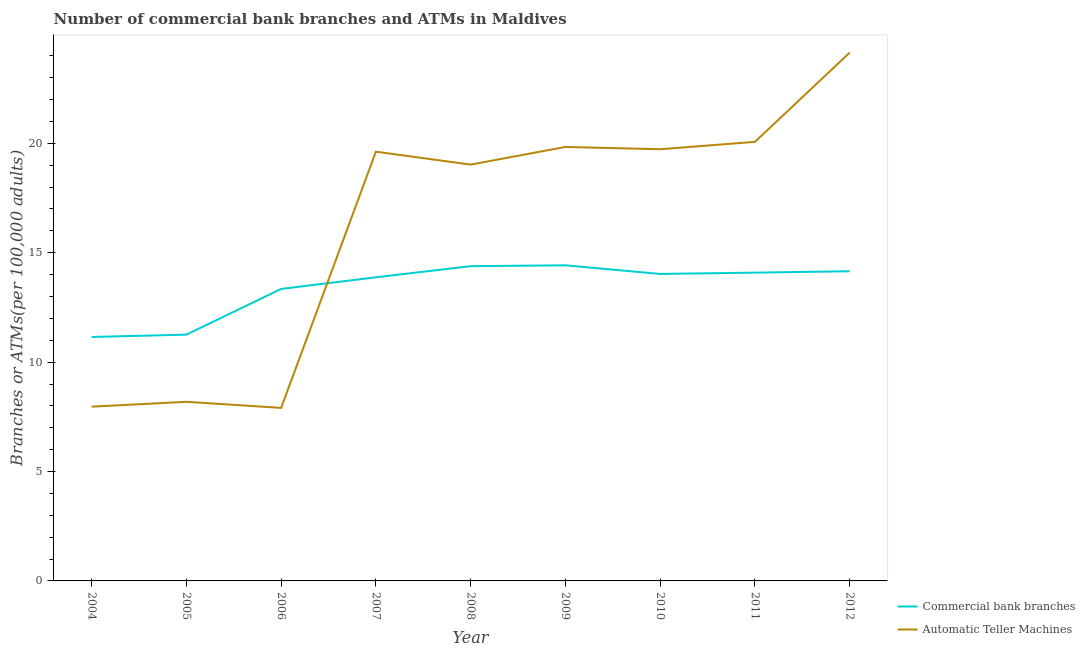What is the number of commercal bank branches in 2010?
Provide a succinct answer. 14.03. Across all years, what is the maximum number of atms?
Offer a terse response. 24.15. Across all years, what is the minimum number of atms?
Ensure brevity in your answer.  7.91. In which year was the number of commercal bank branches minimum?
Make the answer very short. 2004. What is the total number of atms in the graph?
Keep it short and to the point. 146.49. What is the difference between the number of atms in 2007 and that in 2010?
Your response must be concise. -0.11. What is the difference between the number of commercal bank branches in 2004 and the number of atms in 2008?
Ensure brevity in your answer.  -7.88. What is the average number of commercal bank branches per year?
Your answer should be compact. 13.41. In the year 2010, what is the difference between the number of commercal bank branches and number of atms?
Offer a terse response. -5.7. What is the ratio of the number of atms in 2007 to that in 2008?
Ensure brevity in your answer.  1.03. What is the difference between the highest and the second highest number of commercal bank branches?
Keep it short and to the point. 0.04. What is the difference between the highest and the lowest number of commercal bank branches?
Make the answer very short. 3.28. In how many years, is the number of atms greater than the average number of atms taken over all years?
Keep it short and to the point. 6. Does the number of commercal bank branches monotonically increase over the years?
Provide a succinct answer. No. Is the number of commercal bank branches strictly less than the number of atms over the years?
Offer a terse response. No. How many years are there in the graph?
Provide a succinct answer. 9. What is the difference between two consecutive major ticks on the Y-axis?
Provide a succinct answer. 5. Are the values on the major ticks of Y-axis written in scientific E-notation?
Provide a succinct answer. No. Does the graph contain any zero values?
Make the answer very short. No. Does the graph contain grids?
Offer a terse response. No. Where does the legend appear in the graph?
Offer a terse response. Bottom right. What is the title of the graph?
Provide a succinct answer. Number of commercial bank branches and ATMs in Maldives. What is the label or title of the Y-axis?
Your response must be concise. Branches or ATMs(per 100,0 adults). What is the Branches or ATMs(per 100,000 adults) of Commercial bank branches in 2004?
Ensure brevity in your answer.  11.15. What is the Branches or ATMs(per 100,000 adults) of Automatic Teller Machines in 2004?
Your response must be concise. 7.96. What is the Branches or ATMs(per 100,000 adults) of Commercial bank branches in 2005?
Offer a very short reply. 11.26. What is the Branches or ATMs(per 100,000 adults) of Automatic Teller Machines in 2005?
Offer a very short reply. 8.19. What is the Branches or ATMs(per 100,000 adults) in Commercial bank branches in 2006?
Offer a terse response. 13.35. What is the Branches or ATMs(per 100,000 adults) in Automatic Teller Machines in 2006?
Ensure brevity in your answer.  7.91. What is the Branches or ATMs(per 100,000 adults) in Commercial bank branches in 2007?
Ensure brevity in your answer.  13.88. What is the Branches or ATMs(per 100,000 adults) in Automatic Teller Machines in 2007?
Give a very brief answer. 19.62. What is the Branches or ATMs(per 100,000 adults) of Commercial bank branches in 2008?
Your answer should be very brief. 14.39. What is the Branches or ATMs(per 100,000 adults) of Automatic Teller Machines in 2008?
Your answer should be compact. 19.03. What is the Branches or ATMs(per 100,000 adults) of Commercial bank branches in 2009?
Your response must be concise. 14.43. What is the Branches or ATMs(per 100,000 adults) in Automatic Teller Machines in 2009?
Your answer should be very brief. 19.83. What is the Branches or ATMs(per 100,000 adults) of Commercial bank branches in 2010?
Give a very brief answer. 14.03. What is the Branches or ATMs(per 100,000 adults) of Automatic Teller Machines in 2010?
Your answer should be compact. 19.73. What is the Branches or ATMs(per 100,000 adults) of Commercial bank branches in 2011?
Ensure brevity in your answer.  14.09. What is the Branches or ATMs(per 100,000 adults) of Automatic Teller Machines in 2011?
Your answer should be very brief. 20.07. What is the Branches or ATMs(per 100,000 adults) of Commercial bank branches in 2012?
Your answer should be very brief. 14.15. What is the Branches or ATMs(per 100,000 adults) in Automatic Teller Machines in 2012?
Keep it short and to the point. 24.15. Across all years, what is the maximum Branches or ATMs(per 100,000 adults) in Commercial bank branches?
Keep it short and to the point. 14.43. Across all years, what is the maximum Branches or ATMs(per 100,000 adults) in Automatic Teller Machines?
Your answer should be very brief. 24.15. Across all years, what is the minimum Branches or ATMs(per 100,000 adults) in Commercial bank branches?
Give a very brief answer. 11.15. Across all years, what is the minimum Branches or ATMs(per 100,000 adults) in Automatic Teller Machines?
Offer a very short reply. 7.91. What is the total Branches or ATMs(per 100,000 adults) in Commercial bank branches in the graph?
Your answer should be very brief. 120.72. What is the total Branches or ATMs(per 100,000 adults) in Automatic Teller Machines in the graph?
Offer a very short reply. 146.49. What is the difference between the Branches or ATMs(per 100,000 adults) of Commercial bank branches in 2004 and that in 2005?
Provide a succinct answer. -0.11. What is the difference between the Branches or ATMs(per 100,000 adults) in Automatic Teller Machines in 2004 and that in 2005?
Your response must be concise. -0.22. What is the difference between the Branches or ATMs(per 100,000 adults) of Commercial bank branches in 2004 and that in 2006?
Offer a very short reply. -2.2. What is the difference between the Branches or ATMs(per 100,000 adults) in Automatic Teller Machines in 2004 and that in 2006?
Offer a very short reply. 0.05. What is the difference between the Branches or ATMs(per 100,000 adults) in Commercial bank branches in 2004 and that in 2007?
Your response must be concise. -2.73. What is the difference between the Branches or ATMs(per 100,000 adults) in Automatic Teller Machines in 2004 and that in 2007?
Keep it short and to the point. -11.66. What is the difference between the Branches or ATMs(per 100,000 adults) of Commercial bank branches in 2004 and that in 2008?
Provide a short and direct response. -3.24. What is the difference between the Branches or ATMs(per 100,000 adults) in Automatic Teller Machines in 2004 and that in 2008?
Provide a succinct answer. -11.06. What is the difference between the Branches or ATMs(per 100,000 adults) of Commercial bank branches in 2004 and that in 2009?
Your response must be concise. -3.28. What is the difference between the Branches or ATMs(per 100,000 adults) of Automatic Teller Machines in 2004 and that in 2009?
Ensure brevity in your answer.  -11.87. What is the difference between the Branches or ATMs(per 100,000 adults) of Commercial bank branches in 2004 and that in 2010?
Your answer should be compact. -2.88. What is the difference between the Branches or ATMs(per 100,000 adults) in Automatic Teller Machines in 2004 and that in 2010?
Make the answer very short. -11.77. What is the difference between the Branches or ATMs(per 100,000 adults) in Commercial bank branches in 2004 and that in 2011?
Provide a succinct answer. -2.94. What is the difference between the Branches or ATMs(per 100,000 adults) of Automatic Teller Machines in 2004 and that in 2011?
Your response must be concise. -12.1. What is the difference between the Branches or ATMs(per 100,000 adults) in Commercial bank branches in 2004 and that in 2012?
Provide a short and direct response. -3. What is the difference between the Branches or ATMs(per 100,000 adults) of Automatic Teller Machines in 2004 and that in 2012?
Give a very brief answer. -16.18. What is the difference between the Branches or ATMs(per 100,000 adults) in Commercial bank branches in 2005 and that in 2006?
Provide a short and direct response. -2.09. What is the difference between the Branches or ATMs(per 100,000 adults) in Automatic Teller Machines in 2005 and that in 2006?
Provide a succinct answer. 0.28. What is the difference between the Branches or ATMs(per 100,000 adults) of Commercial bank branches in 2005 and that in 2007?
Give a very brief answer. -2.62. What is the difference between the Branches or ATMs(per 100,000 adults) in Automatic Teller Machines in 2005 and that in 2007?
Your answer should be very brief. -11.43. What is the difference between the Branches or ATMs(per 100,000 adults) in Commercial bank branches in 2005 and that in 2008?
Provide a short and direct response. -3.13. What is the difference between the Branches or ATMs(per 100,000 adults) in Automatic Teller Machines in 2005 and that in 2008?
Keep it short and to the point. -10.84. What is the difference between the Branches or ATMs(per 100,000 adults) in Commercial bank branches in 2005 and that in 2009?
Your response must be concise. -3.17. What is the difference between the Branches or ATMs(per 100,000 adults) of Automatic Teller Machines in 2005 and that in 2009?
Keep it short and to the point. -11.65. What is the difference between the Branches or ATMs(per 100,000 adults) in Commercial bank branches in 2005 and that in 2010?
Your response must be concise. -2.77. What is the difference between the Branches or ATMs(per 100,000 adults) in Automatic Teller Machines in 2005 and that in 2010?
Keep it short and to the point. -11.54. What is the difference between the Branches or ATMs(per 100,000 adults) in Commercial bank branches in 2005 and that in 2011?
Offer a very short reply. -2.83. What is the difference between the Branches or ATMs(per 100,000 adults) in Automatic Teller Machines in 2005 and that in 2011?
Your answer should be very brief. -11.88. What is the difference between the Branches or ATMs(per 100,000 adults) of Commercial bank branches in 2005 and that in 2012?
Keep it short and to the point. -2.9. What is the difference between the Branches or ATMs(per 100,000 adults) in Automatic Teller Machines in 2005 and that in 2012?
Provide a short and direct response. -15.96. What is the difference between the Branches or ATMs(per 100,000 adults) in Commercial bank branches in 2006 and that in 2007?
Give a very brief answer. -0.53. What is the difference between the Branches or ATMs(per 100,000 adults) of Automatic Teller Machines in 2006 and that in 2007?
Your answer should be compact. -11.71. What is the difference between the Branches or ATMs(per 100,000 adults) in Commercial bank branches in 2006 and that in 2008?
Provide a short and direct response. -1.04. What is the difference between the Branches or ATMs(per 100,000 adults) of Automatic Teller Machines in 2006 and that in 2008?
Make the answer very short. -11.12. What is the difference between the Branches or ATMs(per 100,000 adults) in Commercial bank branches in 2006 and that in 2009?
Provide a succinct answer. -1.08. What is the difference between the Branches or ATMs(per 100,000 adults) in Automatic Teller Machines in 2006 and that in 2009?
Provide a succinct answer. -11.93. What is the difference between the Branches or ATMs(per 100,000 adults) in Commercial bank branches in 2006 and that in 2010?
Ensure brevity in your answer.  -0.68. What is the difference between the Branches or ATMs(per 100,000 adults) in Automatic Teller Machines in 2006 and that in 2010?
Provide a short and direct response. -11.82. What is the difference between the Branches or ATMs(per 100,000 adults) of Commercial bank branches in 2006 and that in 2011?
Ensure brevity in your answer.  -0.74. What is the difference between the Branches or ATMs(per 100,000 adults) of Automatic Teller Machines in 2006 and that in 2011?
Offer a very short reply. -12.16. What is the difference between the Branches or ATMs(per 100,000 adults) of Commercial bank branches in 2006 and that in 2012?
Your answer should be compact. -0.81. What is the difference between the Branches or ATMs(per 100,000 adults) of Automatic Teller Machines in 2006 and that in 2012?
Your response must be concise. -16.24. What is the difference between the Branches or ATMs(per 100,000 adults) in Commercial bank branches in 2007 and that in 2008?
Provide a short and direct response. -0.51. What is the difference between the Branches or ATMs(per 100,000 adults) of Automatic Teller Machines in 2007 and that in 2008?
Your answer should be compact. 0.59. What is the difference between the Branches or ATMs(per 100,000 adults) in Commercial bank branches in 2007 and that in 2009?
Give a very brief answer. -0.55. What is the difference between the Branches or ATMs(per 100,000 adults) of Automatic Teller Machines in 2007 and that in 2009?
Your response must be concise. -0.22. What is the difference between the Branches or ATMs(per 100,000 adults) in Commercial bank branches in 2007 and that in 2010?
Offer a terse response. -0.15. What is the difference between the Branches or ATMs(per 100,000 adults) of Automatic Teller Machines in 2007 and that in 2010?
Your answer should be very brief. -0.11. What is the difference between the Branches or ATMs(per 100,000 adults) of Commercial bank branches in 2007 and that in 2011?
Offer a terse response. -0.21. What is the difference between the Branches or ATMs(per 100,000 adults) in Automatic Teller Machines in 2007 and that in 2011?
Offer a terse response. -0.45. What is the difference between the Branches or ATMs(per 100,000 adults) of Commercial bank branches in 2007 and that in 2012?
Your answer should be very brief. -0.28. What is the difference between the Branches or ATMs(per 100,000 adults) in Automatic Teller Machines in 2007 and that in 2012?
Provide a succinct answer. -4.53. What is the difference between the Branches or ATMs(per 100,000 adults) in Commercial bank branches in 2008 and that in 2009?
Provide a short and direct response. -0.04. What is the difference between the Branches or ATMs(per 100,000 adults) of Automatic Teller Machines in 2008 and that in 2009?
Your answer should be compact. -0.81. What is the difference between the Branches or ATMs(per 100,000 adults) of Commercial bank branches in 2008 and that in 2010?
Ensure brevity in your answer.  0.36. What is the difference between the Branches or ATMs(per 100,000 adults) in Automatic Teller Machines in 2008 and that in 2010?
Make the answer very short. -0.7. What is the difference between the Branches or ATMs(per 100,000 adults) of Commercial bank branches in 2008 and that in 2011?
Give a very brief answer. 0.3. What is the difference between the Branches or ATMs(per 100,000 adults) of Automatic Teller Machines in 2008 and that in 2011?
Your response must be concise. -1.04. What is the difference between the Branches or ATMs(per 100,000 adults) of Commercial bank branches in 2008 and that in 2012?
Your answer should be compact. 0.23. What is the difference between the Branches or ATMs(per 100,000 adults) of Automatic Teller Machines in 2008 and that in 2012?
Your answer should be compact. -5.12. What is the difference between the Branches or ATMs(per 100,000 adults) of Commercial bank branches in 2009 and that in 2010?
Ensure brevity in your answer.  0.39. What is the difference between the Branches or ATMs(per 100,000 adults) of Automatic Teller Machines in 2009 and that in 2010?
Provide a short and direct response. 0.1. What is the difference between the Branches or ATMs(per 100,000 adults) in Commercial bank branches in 2009 and that in 2011?
Your response must be concise. 0.33. What is the difference between the Branches or ATMs(per 100,000 adults) in Automatic Teller Machines in 2009 and that in 2011?
Offer a terse response. -0.23. What is the difference between the Branches or ATMs(per 100,000 adults) of Commercial bank branches in 2009 and that in 2012?
Keep it short and to the point. 0.27. What is the difference between the Branches or ATMs(per 100,000 adults) in Automatic Teller Machines in 2009 and that in 2012?
Make the answer very short. -4.31. What is the difference between the Branches or ATMs(per 100,000 adults) in Commercial bank branches in 2010 and that in 2011?
Your answer should be very brief. -0.06. What is the difference between the Branches or ATMs(per 100,000 adults) of Automatic Teller Machines in 2010 and that in 2011?
Provide a short and direct response. -0.34. What is the difference between the Branches or ATMs(per 100,000 adults) in Commercial bank branches in 2010 and that in 2012?
Keep it short and to the point. -0.12. What is the difference between the Branches or ATMs(per 100,000 adults) in Automatic Teller Machines in 2010 and that in 2012?
Offer a very short reply. -4.42. What is the difference between the Branches or ATMs(per 100,000 adults) in Commercial bank branches in 2011 and that in 2012?
Ensure brevity in your answer.  -0.06. What is the difference between the Branches or ATMs(per 100,000 adults) of Automatic Teller Machines in 2011 and that in 2012?
Ensure brevity in your answer.  -4.08. What is the difference between the Branches or ATMs(per 100,000 adults) of Commercial bank branches in 2004 and the Branches or ATMs(per 100,000 adults) of Automatic Teller Machines in 2005?
Offer a very short reply. 2.96. What is the difference between the Branches or ATMs(per 100,000 adults) in Commercial bank branches in 2004 and the Branches or ATMs(per 100,000 adults) in Automatic Teller Machines in 2006?
Give a very brief answer. 3.24. What is the difference between the Branches or ATMs(per 100,000 adults) of Commercial bank branches in 2004 and the Branches or ATMs(per 100,000 adults) of Automatic Teller Machines in 2007?
Your response must be concise. -8.47. What is the difference between the Branches or ATMs(per 100,000 adults) in Commercial bank branches in 2004 and the Branches or ATMs(per 100,000 adults) in Automatic Teller Machines in 2008?
Provide a succinct answer. -7.88. What is the difference between the Branches or ATMs(per 100,000 adults) in Commercial bank branches in 2004 and the Branches or ATMs(per 100,000 adults) in Automatic Teller Machines in 2009?
Your response must be concise. -8.69. What is the difference between the Branches or ATMs(per 100,000 adults) of Commercial bank branches in 2004 and the Branches or ATMs(per 100,000 adults) of Automatic Teller Machines in 2010?
Your response must be concise. -8.58. What is the difference between the Branches or ATMs(per 100,000 adults) of Commercial bank branches in 2004 and the Branches or ATMs(per 100,000 adults) of Automatic Teller Machines in 2011?
Your response must be concise. -8.92. What is the difference between the Branches or ATMs(per 100,000 adults) in Commercial bank branches in 2004 and the Branches or ATMs(per 100,000 adults) in Automatic Teller Machines in 2012?
Keep it short and to the point. -13. What is the difference between the Branches or ATMs(per 100,000 adults) in Commercial bank branches in 2005 and the Branches or ATMs(per 100,000 adults) in Automatic Teller Machines in 2006?
Provide a short and direct response. 3.35. What is the difference between the Branches or ATMs(per 100,000 adults) of Commercial bank branches in 2005 and the Branches or ATMs(per 100,000 adults) of Automatic Teller Machines in 2007?
Your answer should be very brief. -8.36. What is the difference between the Branches or ATMs(per 100,000 adults) of Commercial bank branches in 2005 and the Branches or ATMs(per 100,000 adults) of Automatic Teller Machines in 2008?
Provide a succinct answer. -7.77. What is the difference between the Branches or ATMs(per 100,000 adults) in Commercial bank branches in 2005 and the Branches or ATMs(per 100,000 adults) in Automatic Teller Machines in 2009?
Make the answer very short. -8.58. What is the difference between the Branches or ATMs(per 100,000 adults) of Commercial bank branches in 2005 and the Branches or ATMs(per 100,000 adults) of Automatic Teller Machines in 2010?
Your response must be concise. -8.47. What is the difference between the Branches or ATMs(per 100,000 adults) in Commercial bank branches in 2005 and the Branches or ATMs(per 100,000 adults) in Automatic Teller Machines in 2011?
Offer a very short reply. -8.81. What is the difference between the Branches or ATMs(per 100,000 adults) of Commercial bank branches in 2005 and the Branches or ATMs(per 100,000 adults) of Automatic Teller Machines in 2012?
Provide a short and direct response. -12.89. What is the difference between the Branches or ATMs(per 100,000 adults) in Commercial bank branches in 2006 and the Branches or ATMs(per 100,000 adults) in Automatic Teller Machines in 2007?
Make the answer very short. -6.27. What is the difference between the Branches or ATMs(per 100,000 adults) in Commercial bank branches in 2006 and the Branches or ATMs(per 100,000 adults) in Automatic Teller Machines in 2008?
Your answer should be compact. -5.68. What is the difference between the Branches or ATMs(per 100,000 adults) of Commercial bank branches in 2006 and the Branches or ATMs(per 100,000 adults) of Automatic Teller Machines in 2009?
Keep it short and to the point. -6.49. What is the difference between the Branches or ATMs(per 100,000 adults) in Commercial bank branches in 2006 and the Branches or ATMs(per 100,000 adults) in Automatic Teller Machines in 2010?
Provide a short and direct response. -6.38. What is the difference between the Branches or ATMs(per 100,000 adults) in Commercial bank branches in 2006 and the Branches or ATMs(per 100,000 adults) in Automatic Teller Machines in 2011?
Offer a terse response. -6.72. What is the difference between the Branches or ATMs(per 100,000 adults) of Commercial bank branches in 2006 and the Branches or ATMs(per 100,000 adults) of Automatic Teller Machines in 2012?
Offer a terse response. -10.8. What is the difference between the Branches or ATMs(per 100,000 adults) in Commercial bank branches in 2007 and the Branches or ATMs(per 100,000 adults) in Automatic Teller Machines in 2008?
Ensure brevity in your answer.  -5.15. What is the difference between the Branches or ATMs(per 100,000 adults) of Commercial bank branches in 2007 and the Branches or ATMs(per 100,000 adults) of Automatic Teller Machines in 2009?
Provide a short and direct response. -5.96. What is the difference between the Branches or ATMs(per 100,000 adults) of Commercial bank branches in 2007 and the Branches or ATMs(per 100,000 adults) of Automatic Teller Machines in 2010?
Keep it short and to the point. -5.85. What is the difference between the Branches or ATMs(per 100,000 adults) in Commercial bank branches in 2007 and the Branches or ATMs(per 100,000 adults) in Automatic Teller Machines in 2011?
Keep it short and to the point. -6.19. What is the difference between the Branches or ATMs(per 100,000 adults) of Commercial bank branches in 2007 and the Branches or ATMs(per 100,000 adults) of Automatic Teller Machines in 2012?
Ensure brevity in your answer.  -10.27. What is the difference between the Branches or ATMs(per 100,000 adults) of Commercial bank branches in 2008 and the Branches or ATMs(per 100,000 adults) of Automatic Teller Machines in 2009?
Offer a very short reply. -5.45. What is the difference between the Branches or ATMs(per 100,000 adults) of Commercial bank branches in 2008 and the Branches or ATMs(per 100,000 adults) of Automatic Teller Machines in 2010?
Your answer should be very brief. -5.34. What is the difference between the Branches or ATMs(per 100,000 adults) of Commercial bank branches in 2008 and the Branches or ATMs(per 100,000 adults) of Automatic Teller Machines in 2011?
Your response must be concise. -5.68. What is the difference between the Branches or ATMs(per 100,000 adults) of Commercial bank branches in 2008 and the Branches or ATMs(per 100,000 adults) of Automatic Teller Machines in 2012?
Offer a terse response. -9.76. What is the difference between the Branches or ATMs(per 100,000 adults) in Commercial bank branches in 2009 and the Branches or ATMs(per 100,000 adults) in Automatic Teller Machines in 2010?
Keep it short and to the point. -5.31. What is the difference between the Branches or ATMs(per 100,000 adults) of Commercial bank branches in 2009 and the Branches or ATMs(per 100,000 adults) of Automatic Teller Machines in 2011?
Keep it short and to the point. -5.64. What is the difference between the Branches or ATMs(per 100,000 adults) in Commercial bank branches in 2009 and the Branches or ATMs(per 100,000 adults) in Automatic Teller Machines in 2012?
Offer a terse response. -9.72. What is the difference between the Branches or ATMs(per 100,000 adults) in Commercial bank branches in 2010 and the Branches or ATMs(per 100,000 adults) in Automatic Teller Machines in 2011?
Keep it short and to the point. -6.04. What is the difference between the Branches or ATMs(per 100,000 adults) in Commercial bank branches in 2010 and the Branches or ATMs(per 100,000 adults) in Automatic Teller Machines in 2012?
Your answer should be very brief. -10.12. What is the difference between the Branches or ATMs(per 100,000 adults) in Commercial bank branches in 2011 and the Branches or ATMs(per 100,000 adults) in Automatic Teller Machines in 2012?
Give a very brief answer. -10.06. What is the average Branches or ATMs(per 100,000 adults) of Commercial bank branches per year?
Ensure brevity in your answer.  13.41. What is the average Branches or ATMs(per 100,000 adults) in Automatic Teller Machines per year?
Ensure brevity in your answer.  16.28. In the year 2004, what is the difference between the Branches or ATMs(per 100,000 adults) in Commercial bank branches and Branches or ATMs(per 100,000 adults) in Automatic Teller Machines?
Offer a very short reply. 3.19. In the year 2005, what is the difference between the Branches or ATMs(per 100,000 adults) in Commercial bank branches and Branches or ATMs(per 100,000 adults) in Automatic Teller Machines?
Offer a terse response. 3.07. In the year 2006, what is the difference between the Branches or ATMs(per 100,000 adults) in Commercial bank branches and Branches or ATMs(per 100,000 adults) in Automatic Teller Machines?
Your answer should be very brief. 5.44. In the year 2007, what is the difference between the Branches or ATMs(per 100,000 adults) of Commercial bank branches and Branches or ATMs(per 100,000 adults) of Automatic Teller Machines?
Offer a terse response. -5.74. In the year 2008, what is the difference between the Branches or ATMs(per 100,000 adults) in Commercial bank branches and Branches or ATMs(per 100,000 adults) in Automatic Teller Machines?
Ensure brevity in your answer.  -4.64. In the year 2009, what is the difference between the Branches or ATMs(per 100,000 adults) in Commercial bank branches and Branches or ATMs(per 100,000 adults) in Automatic Teller Machines?
Your answer should be very brief. -5.41. In the year 2010, what is the difference between the Branches or ATMs(per 100,000 adults) in Commercial bank branches and Branches or ATMs(per 100,000 adults) in Automatic Teller Machines?
Provide a succinct answer. -5.7. In the year 2011, what is the difference between the Branches or ATMs(per 100,000 adults) of Commercial bank branches and Branches or ATMs(per 100,000 adults) of Automatic Teller Machines?
Your response must be concise. -5.98. In the year 2012, what is the difference between the Branches or ATMs(per 100,000 adults) of Commercial bank branches and Branches or ATMs(per 100,000 adults) of Automatic Teller Machines?
Your response must be concise. -9.99. What is the ratio of the Branches or ATMs(per 100,000 adults) of Automatic Teller Machines in 2004 to that in 2005?
Give a very brief answer. 0.97. What is the ratio of the Branches or ATMs(per 100,000 adults) in Commercial bank branches in 2004 to that in 2006?
Offer a very short reply. 0.84. What is the ratio of the Branches or ATMs(per 100,000 adults) of Automatic Teller Machines in 2004 to that in 2006?
Offer a very short reply. 1.01. What is the ratio of the Branches or ATMs(per 100,000 adults) in Commercial bank branches in 2004 to that in 2007?
Your response must be concise. 0.8. What is the ratio of the Branches or ATMs(per 100,000 adults) of Automatic Teller Machines in 2004 to that in 2007?
Provide a succinct answer. 0.41. What is the ratio of the Branches or ATMs(per 100,000 adults) in Commercial bank branches in 2004 to that in 2008?
Make the answer very short. 0.78. What is the ratio of the Branches or ATMs(per 100,000 adults) of Automatic Teller Machines in 2004 to that in 2008?
Make the answer very short. 0.42. What is the ratio of the Branches or ATMs(per 100,000 adults) of Commercial bank branches in 2004 to that in 2009?
Your response must be concise. 0.77. What is the ratio of the Branches or ATMs(per 100,000 adults) in Automatic Teller Machines in 2004 to that in 2009?
Offer a very short reply. 0.4. What is the ratio of the Branches or ATMs(per 100,000 adults) of Commercial bank branches in 2004 to that in 2010?
Provide a succinct answer. 0.79. What is the ratio of the Branches or ATMs(per 100,000 adults) in Automatic Teller Machines in 2004 to that in 2010?
Ensure brevity in your answer.  0.4. What is the ratio of the Branches or ATMs(per 100,000 adults) of Commercial bank branches in 2004 to that in 2011?
Provide a short and direct response. 0.79. What is the ratio of the Branches or ATMs(per 100,000 adults) in Automatic Teller Machines in 2004 to that in 2011?
Keep it short and to the point. 0.4. What is the ratio of the Branches or ATMs(per 100,000 adults) in Commercial bank branches in 2004 to that in 2012?
Your response must be concise. 0.79. What is the ratio of the Branches or ATMs(per 100,000 adults) of Automatic Teller Machines in 2004 to that in 2012?
Offer a very short reply. 0.33. What is the ratio of the Branches or ATMs(per 100,000 adults) of Commercial bank branches in 2005 to that in 2006?
Offer a very short reply. 0.84. What is the ratio of the Branches or ATMs(per 100,000 adults) in Automatic Teller Machines in 2005 to that in 2006?
Keep it short and to the point. 1.04. What is the ratio of the Branches or ATMs(per 100,000 adults) in Commercial bank branches in 2005 to that in 2007?
Keep it short and to the point. 0.81. What is the ratio of the Branches or ATMs(per 100,000 adults) in Automatic Teller Machines in 2005 to that in 2007?
Provide a succinct answer. 0.42. What is the ratio of the Branches or ATMs(per 100,000 adults) of Commercial bank branches in 2005 to that in 2008?
Provide a short and direct response. 0.78. What is the ratio of the Branches or ATMs(per 100,000 adults) of Automatic Teller Machines in 2005 to that in 2008?
Ensure brevity in your answer.  0.43. What is the ratio of the Branches or ATMs(per 100,000 adults) of Commercial bank branches in 2005 to that in 2009?
Your answer should be compact. 0.78. What is the ratio of the Branches or ATMs(per 100,000 adults) in Automatic Teller Machines in 2005 to that in 2009?
Give a very brief answer. 0.41. What is the ratio of the Branches or ATMs(per 100,000 adults) of Commercial bank branches in 2005 to that in 2010?
Make the answer very short. 0.8. What is the ratio of the Branches or ATMs(per 100,000 adults) of Automatic Teller Machines in 2005 to that in 2010?
Ensure brevity in your answer.  0.41. What is the ratio of the Branches or ATMs(per 100,000 adults) of Commercial bank branches in 2005 to that in 2011?
Keep it short and to the point. 0.8. What is the ratio of the Branches or ATMs(per 100,000 adults) of Automatic Teller Machines in 2005 to that in 2011?
Your answer should be very brief. 0.41. What is the ratio of the Branches or ATMs(per 100,000 adults) of Commercial bank branches in 2005 to that in 2012?
Ensure brevity in your answer.  0.8. What is the ratio of the Branches or ATMs(per 100,000 adults) of Automatic Teller Machines in 2005 to that in 2012?
Offer a terse response. 0.34. What is the ratio of the Branches or ATMs(per 100,000 adults) in Commercial bank branches in 2006 to that in 2007?
Provide a succinct answer. 0.96. What is the ratio of the Branches or ATMs(per 100,000 adults) of Automatic Teller Machines in 2006 to that in 2007?
Give a very brief answer. 0.4. What is the ratio of the Branches or ATMs(per 100,000 adults) of Commercial bank branches in 2006 to that in 2008?
Your answer should be very brief. 0.93. What is the ratio of the Branches or ATMs(per 100,000 adults) in Automatic Teller Machines in 2006 to that in 2008?
Keep it short and to the point. 0.42. What is the ratio of the Branches or ATMs(per 100,000 adults) in Commercial bank branches in 2006 to that in 2009?
Your answer should be very brief. 0.93. What is the ratio of the Branches or ATMs(per 100,000 adults) of Automatic Teller Machines in 2006 to that in 2009?
Your response must be concise. 0.4. What is the ratio of the Branches or ATMs(per 100,000 adults) of Commercial bank branches in 2006 to that in 2010?
Provide a short and direct response. 0.95. What is the ratio of the Branches or ATMs(per 100,000 adults) in Automatic Teller Machines in 2006 to that in 2010?
Provide a succinct answer. 0.4. What is the ratio of the Branches or ATMs(per 100,000 adults) in Commercial bank branches in 2006 to that in 2011?
Ensure brevity in your answer.  0.95. What is the ratio of the Branches or ATMs(per 100,000 adults) of Automatic Teller Machines in 2006 to that in 2011?
Offer a very short reply. 0.39. What is the ratio of the Branches or ATMs(per 100,000 adults) in Commercial bank branches in 2006 to that in 2012?
Your answer should be compact. 0.94. What is the ratio of the Branches or ATMs(per 100,000 adults) in Automatic Teller Machines in 2006 to that in 2012?
Provide a short and direct response. 0.33. What is the ratio of the Branches or ATMs(per 100,000 adults) of Commercial bank branches in 2007 to that in 2008?
Your answer should be compact. 0.96. What is the ratio of the Branches or ATMs(per 100,000 adults) in Automatic Teller Machines in 2007 to that in 2008?
Offer a terse response. 1.03. What is the ratio of the Branches or ATMs(per 100,000 adults) of Commercial bank branches in 2007 to that in 2009?
Keep it short and to the point. 0.96. What is the ratio of the Branches or ATMs(per 100,000 adults) of Commercial bank branches in 2007 to that in 2010?
Your response must be concise. 0.99. What is the ratio of the Branches or ATMs(per 100,000 adults) in Commercial bank branches in 2007 to that in 2011?
Your response must be concise. 0.98. What is the ratio of the Branches or ATMs(per 100,000 adults) of Automatic Teller Machines in 2007 to that in 2011?
Your answer should be very brief. 0.98. What is the ratio of the Branches or ATMs(per 100,000 adults) of Commercial bank branches in 2007 to that in 2012?
Offer a very short reply. 0.98. What is the ratio of the Branches or ATMs(per 100,000 adults) of Automatic Teller Machines in 2007 to that in 2012?
Offer a very short reply. 0.81. What is the ratio of the Branches or ATMs(per 100,000 adults) in Commercial bank branches in 2008 to that in 2009?
Provide a short and direct response. 1. What is the ratio of the Branches or ATMs(per 100,000 adults) in Automatic Teller Machines in 2008 to that in 2009?
Offer a terse response. 0.96. What is the ratio of the Branches or ATMs(per 100,000 adults) of Commercial bank branches in 2008 to that in 2010?
Your answer should be compact. 1.03. What is the ratio of the Branches or ATMs(per 100,000 adults) in Automatic Teller Machines in 2008 to that in 2010?
Offer a terse response. 0.96. What is the ratio of the Branches or ATMs(per 100,000 adults) of Automatic Teller Machines in 2008 to that in 2011?
Your answer should be compact. 0.95. What is the ratio of the Branches or ATMs(per 100,000 adults) in Commercial bank branches in 2008 to that in 2012?
Offer a terse response. 1.02. What is the ratio of the Branches or ATMs(per 100,000 adults) of Automatic Teller Machines in 2008 to that in 2012?
Keep it short and to the point. 0.79. What is the ratio of the Branches or ATMs(per 100,000 adults) in Commercial bank branches in 2009 to that in 2010?
Make the answer very short. 1.03. What is the ratio of the Branches or ATMs(per 100,000 adults) in Automatic Teller Machines in 2009 to that in 2010?
Your answer should be very brief. 1.01. What is the ratio of the Branches or ATMs(per 100,000 adults) in Commercial bank branches in 2009 to that in 2011?
Keep it short and to the point. 1.02. What is the ratio of the Branches or ATMs(per 100,000 adults) of Automatic Teller Machines in 2009 to that in 2011?
Your answer should be compact. 0.99. What is the ratio of the Branches or ATMs(per 100,000 adults) of Commercial bank branches in 2009 to that in 2012?
Make the answer very short. 1.02. What is the ratio of the Branches or ATMs(per 100,000 adults) of Automatic Teller Machines in 2009 to that in 2012?
Offer a terse response. 0.82. What is the ratio of the Branches or ATMs(per 100,000 adults) of Automatic Teller Machines in 2010 to that in 2011?
Keep it short and to the point. 0.98. What is the ratio of the Branches or ATMs(per 100,000 adults) in Commercial bank branches in 2010 to that in 2012?
Your answer should be very brief. 0.99. What is the ratio of the Branches or ATMs(per 100,000 adults) of Automatic Teller Machines in 2010 to that in 2012?
Offer a terse response. 0.82. What is the ratio of the Branches or ATMs(per 100,000 adults) of Commercial bank branches in 2011 to that in 2012?
Make the answer very short. 1. What is the ratio of the Branches or ATMs(per 100,000 adults) of Automatic Teller Machines in 2011 to that in 2012?
Offer a terse response. 0.83. What is the difference between the highest and the second highest Branches or ATMs(per 100,000 adults) in Commercial bank branches?
Your response must be concise. 0.04. What is the difference between the highest and the second highest Branches or ATMs(per 100,000 adults) in Automatic Teller Machines?
Keep it short and to the point. 4.08. What is the difference between the highest and the lowest Branches or ATMs(per 100,000 adults) of Commercial bank branches?
Make the answer very short. 3.28. What is the difference between the highest and the lowest Branches or ATMs(per 100,000 adults) of Automatic Teller Machines?
Provide a short and direct response. 16.24. 